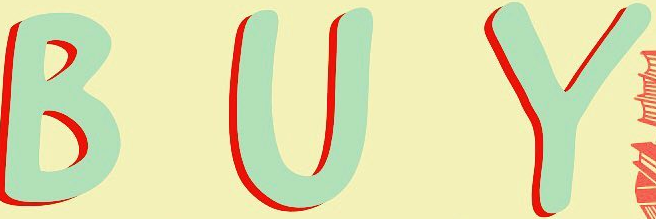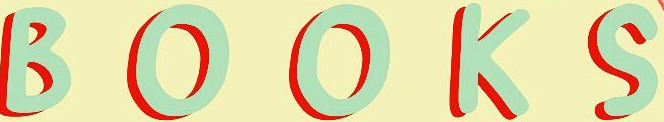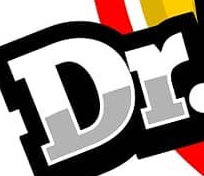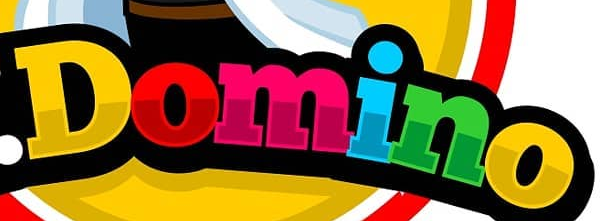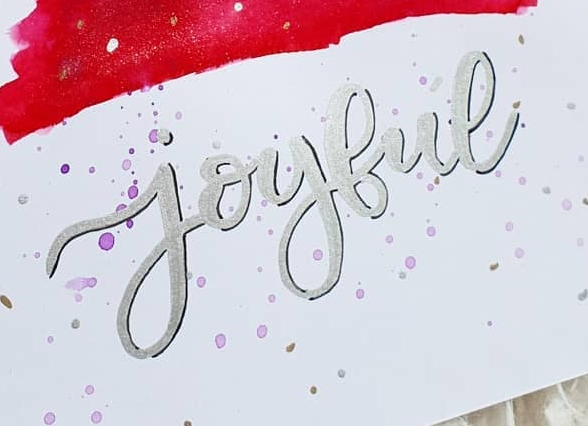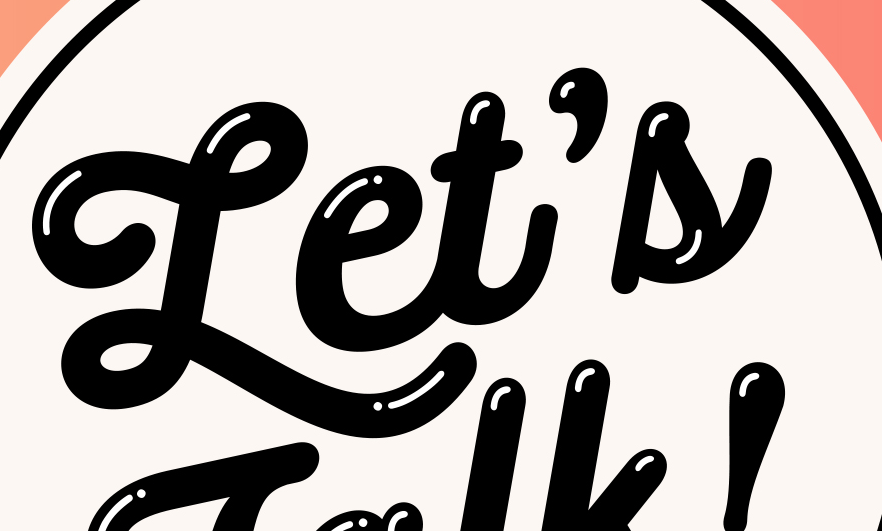Transcribe the words shown in these images in order, separated by a semicolon. BUY; BOOKS; Dr; Domino; joybue; Let's 